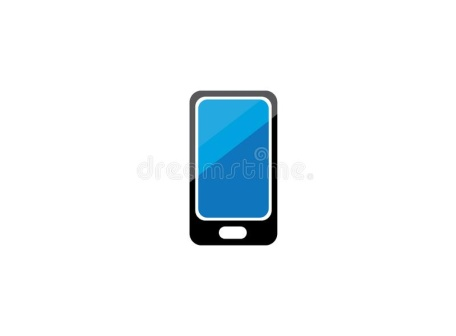This phone looks very futuristic. What kind of technological advancements could it potentially have? Given the sleek and minimalist design, this futuristic phone could potentially be equipped with cutting-edge technologies such as a fully holographic display, capable of projecting interactive 3D images in mid-air. It might also feature an advanced AI assistant that can understand and respond to complex commands intuitively. The phone could include biometric security measures like facial recognition or even DNA scanning for unlocking. Additionally, with advancements in battery technology, it might have an ultra-long battery life powered by a micro-fusion reactor or efficient solar cells embedded in the screen. 